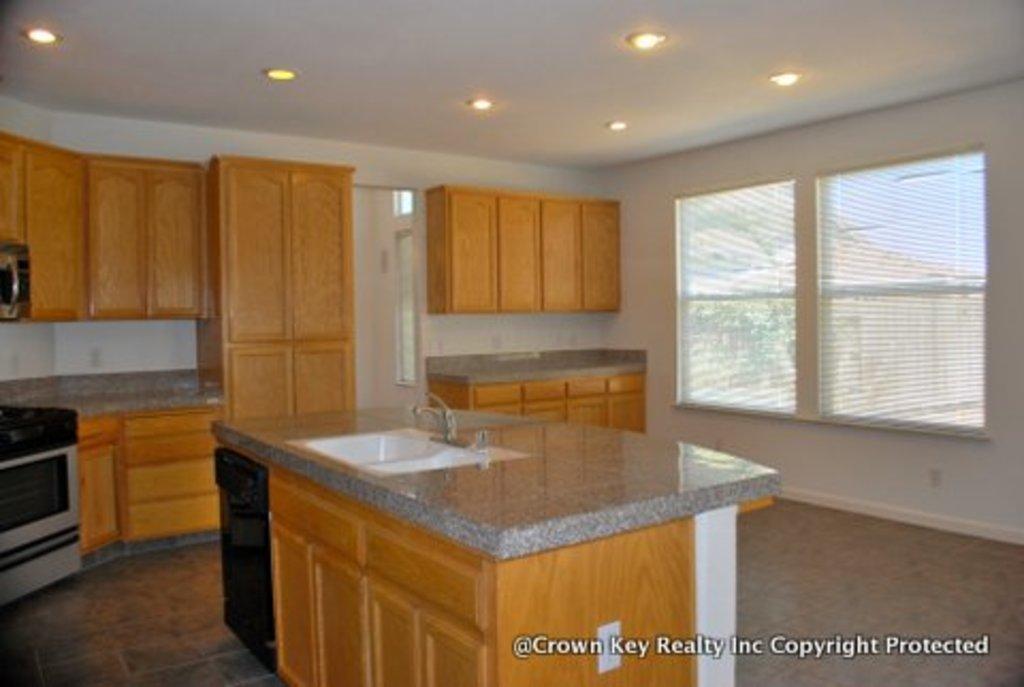What type of space is depicted in the image? There is a room in the image. What furniture or fixtures can be seen in the room? The room contains cupboards and a sink. Are there any plumbing fixtures in the room? Yes, there is a tap present in the room. What is on the floor in the room? There is a glass on the floor. How is the room illuminated? The room has lights on the roof. Is there a way to see outside from the room? Yes, there is a window in the room. What month is it in the image? The image does not provide any information about the month or time of year. How many rings are visible on the tap in the image? There are no rings visible on the tap in the image; only the tap itself is present. 